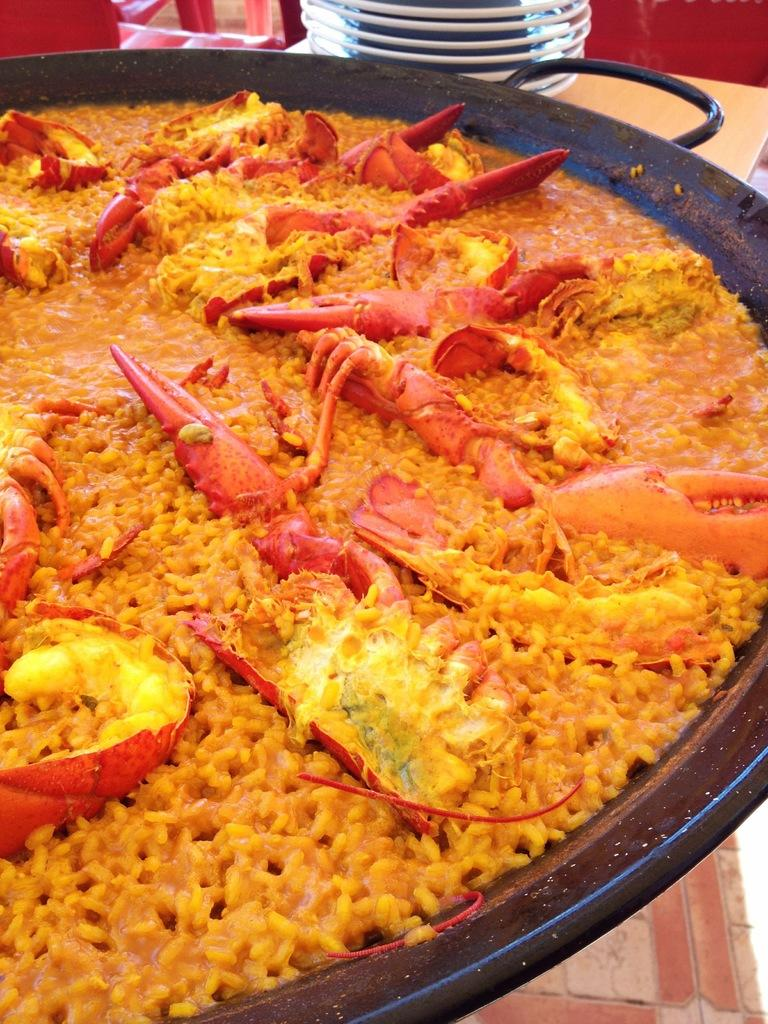What is inside the container in the image? There is food in a container in the image. What else can be seen in the background of the image? There are plates and some objects in the background of the image. What type of surface is the container and plates placed on? There is a table in the image where the container and plates are placed. How many pages can be seen in the image? There are no pages present in the image. 